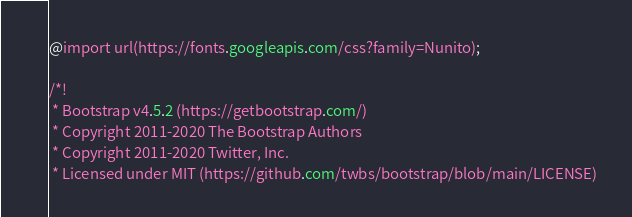<code> <loc_0><loc_0><loc_500><loc_500><_CSS_>@import url(https://fonts.googleapis.com/css?family=Nunito);

/*!
 * Bootstrap v4.5.2 (https://getbootstrap.com/)
 * Copyright 2011-2020 The Bootstrap Authors
 * Copyright 2011-2020 Twitter, Inc.
 * Licensed under MIT (https://github.com/twbs/bootstrap/blob/main/LICENSE)</code> 